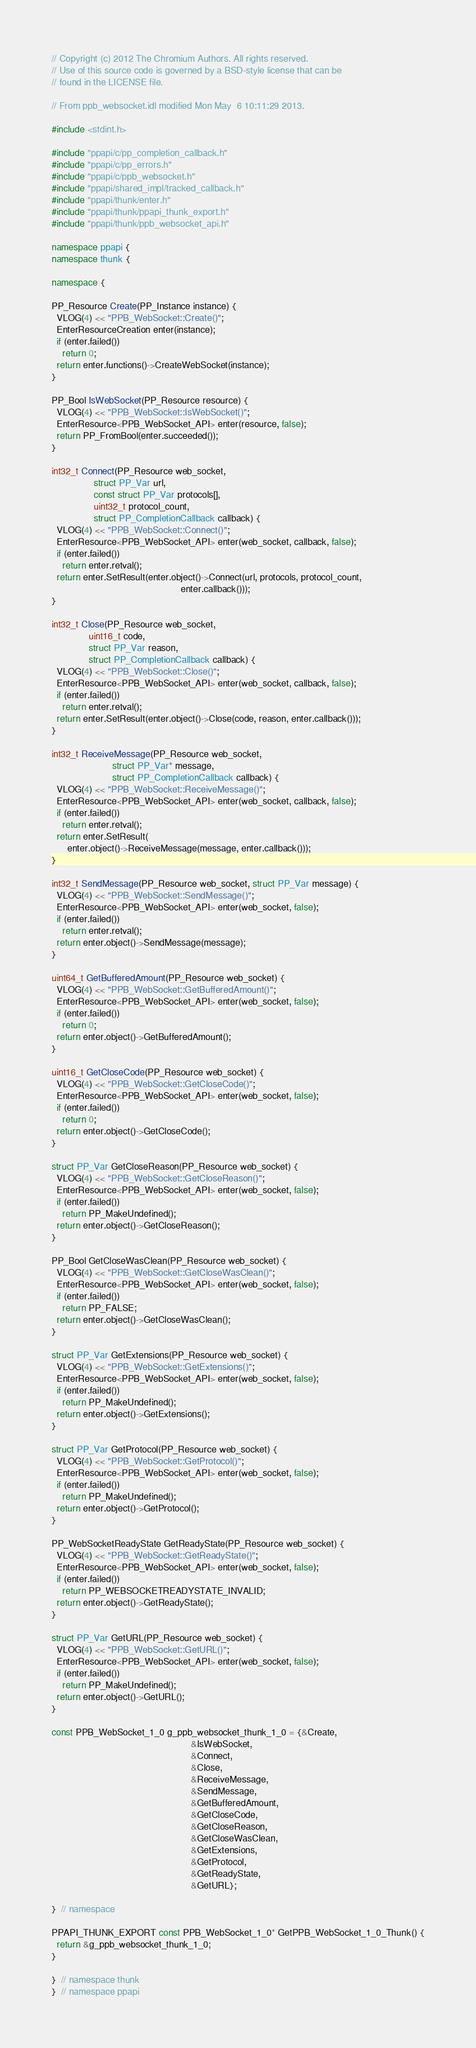<code> <loc_0><loc_0><loc_500><loc_500><_C++_>// Copyright (c) 2012 The Chromium Authors. All rights reserved.
// Use of this source code is governed by a BSD-style license that can be
// found in the LICENSE file.

// From ppb_websocket.idl modified Mon May  6 10:11:29 2013.

#include <stdint.h>

#include "ppapi/c/pp_completion_callback.h"
#include "ppapi/c/pp_errors.h"
#include "ppapi/c/ppb_websocket.h"
#include "ppapi/shared_impl/tracked_callback.h"
#include "ppapi/thunk/enter.h"
#include "ppapi/thunk/ppapi_thunk_export.h"
#include "ppapi/thunk/ppb_websocket_api.h"

namespace ppapi {
namespace thunk {

namespace {

PP_Resource Create(PP_Instance instance) {
  VLOG(4) << "PPB_WebSocket::Create()";
  EnterResourceCreation enter(instance);
  if (enter.failed())
    return 0;
  return enter.functions()->CreateWebSocket(instance);
}

PP_Bool IsWebSocket(PP_Resource resource) {
  VLOG(4) << "PPB_WebSocket::IsWebSocket()";
  EnterResource<PPB_WebSocket_API> enter(resource, false);
  return PP_FromBool(enter.succeeded());
}

int32_t Connect(PP_Resource web_socket,
                struct PP_Var url,
                const struct PP_Var protocols[],
                uint32_t protocol_count,
                struct PP_CompletionCallback callback) {
  VLOG(4) << "PPB_WebSocket::Connect()";
  EnterResource<PPB_WebSocket_API> enter(web_socket, callback, false);
  if (enter.failed())
    return enter.retval();
  return enter.SetResult(enter.object()->Connect(url, protocols, protocol_count,
                                                 enter.callback()));
}

int32_t Close(PP_Resource web_socket,
              uint16_t code,
              struct PP_Var reason,
              struct PP_CompletionCallback callback) {
  VLOG(4) << "PPB_WebSocket::Close()";
  EnterResource<PPB_WebSocket_API> enter(web_socket, callback, false);
  if (enter.failed())
    return enter.retval();
  return enter.SetResult(enter.object()->Close(code, reason, enter.callback()));
}

int32_t ReceiveMessage(PP_Resource web_socket,
                       struct PP_Var* message,
                       struct PP_CompletionCallback callback) {
  VLOG(4) << "PPB_WebSocket::ReceiveMessage()";
  EnterResource<PPB_WebSocket_API> enter(web_socket, callback, false);
  if (enter.failed())
    return enter.retval();
  return enter.SetResult(
      enter.object()->ReceiveMessage(message, enter.callback()));
}

int32_t SendMessage(PP_Resource web_socket, struct PP_Var message) {
  VLOG(4) << "PPB_WebSocket::SendMessage()";
  EnterResource<PPB_WebSocket_API> enter(web_socket, false);
  if (enter.failed())
    return enter.retval();
  return enter.object()->SendMessage(message);
}

uint64_t GetBufferedAmount(PP_Resource web_socket) {
  VLOG(4) << "PPB_WebSocket::GetBufferedAmount()";
  EnterResource<PPB_WebSocket_API> enter(web_socket, false);
  if (enter.failed())
    return 0;
  return enter.object()->GetBufferedAmount();
}

uint16_t GetCloseCode(PP_Resource web_socket) {
  VLOG(4) << "PPB_WebSocket::GetCloseCode()";
  EnterResource<PPB_WebSocket_API> enter(web_socket, false);
  if (enter.failed())
    return 0;
  return enter.object()->GetCloseCode();
}

struct PP_Var GetCloseReason(PP_Resource web_socket) {
  VLOG(4) << "PPB_WebSocket::GetCloseReason()";
  EnterResource<PPB_WebSocket_API> enter(web_socket, false);
  if (enter.failed())
    return PP_MakeUndefined();
  return enter.object()->GetCloseReason();
}

PP_Bool GetCloseWasClean(PP_Resource web_socket) {
  VLOG(4) << "PPB_WebSocket::GetCloseWasClean()";
  EnterResource<PPB_WebSocket_API> enter(web_socket, false);
  if (enter.failed())
    return PP_FALSE;
  return enter.object()->GetCloseWasClean();
}

struct PP_Var GetExtensions(PP_Resource web_socket) {
  VLOG(4) << "PPB_WebSocket::GetExtensions()";
  EnterResource<PPB_WebSocket_API> enter(web_socket, false);
  if (enter.failed())
    return PP_MakeUndefined();
  return enter.object()->GetExtensions();
}

struct PP_Var GetProtocol(PP_Resource web_socket) {
  VLOG(4) << "PPB_WebSocket::GetProtocol()";
  EnterResource<PPB_WebSocket_API> enter(web_socket, false);
  if (enter.failed())
    return PP_MakeUndefined();
  return enter.object()->GetProtocol();
}

PP_WebSocketReadyState GetReadyState(PP_Resource web_socket) {
  VLOG(4) << "PPB_WebSocket::GetReadyState()";
  EnterResource<PPB_WebSocket_API> enter(web_socket, false);
  if (enter.failed())
    return PP_WEBSOCKETREADYSTATE_INVALID;
  return enter.object()->GetReadyState();
}

struct PP_Var GetURL(PP_Resource web_socket) {
  VLOG(4) << "PPB_WebSocket::GetURL()";
  EnterResource<PPB_WebSocket_API> enter(web_socket, false);
  if (enter.failed())
    return PP_MakeUndefined();
  return enter.object()->GetURL();
}

const PPB_WebSocket_1_0 g_ppb_websocket_thunk_1_0 = {&Create,
                                                     &IsWebSocket,
                                                     &Connect,
                                                     &Close,
                                                     &ReceiveMessage,
                                                     &SendMessage,
                                                     &GetBufferedAmount,
                                                     &GetCloseCode,
                                                     &GetCloseReason,
                                                     &GetCloseWasClean,
                                                     &GetExtensions,
                                                     &GetProtocol,
                                                     &GetReadyState,
                                                     &GetURL};

}  // namespace

PPAPI_THUNK_EXPORT const PPB_WebSocket_1_0* GetPPB_WebSocket_1_0_Thunk() {
  return &g_ppb_websocket_thunk_1_0;
}

}  // namespace thunk
}  // namespace ppapi
</code> 